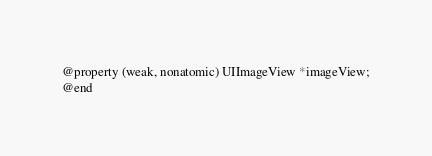<code> <loc_0><loc_0><loc_500><loc_500><_C_>@property (weak, nonatomic) UIImageView *imageView;
@end

</code> 